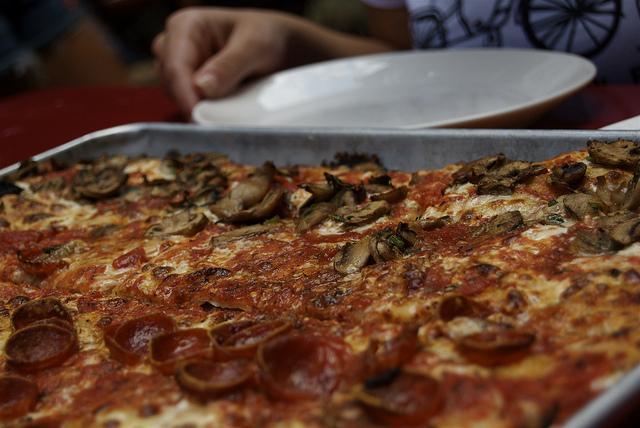Evaluate: Does the caption "The pizza is touching the person." match the image?
Answer yes or no. No. Is "The person is behind the pizza." an appropriate description for the image?
Answer yes or no. Yes. 